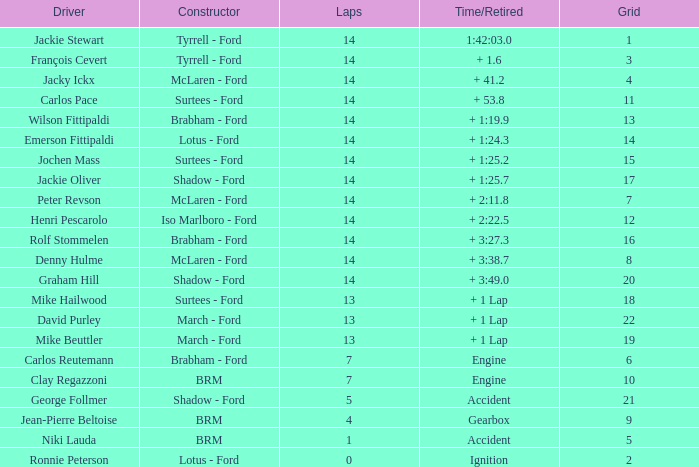What is the low lap total for a grid larger than 16 and has a Time/Retired of + 3:27.3? None. 